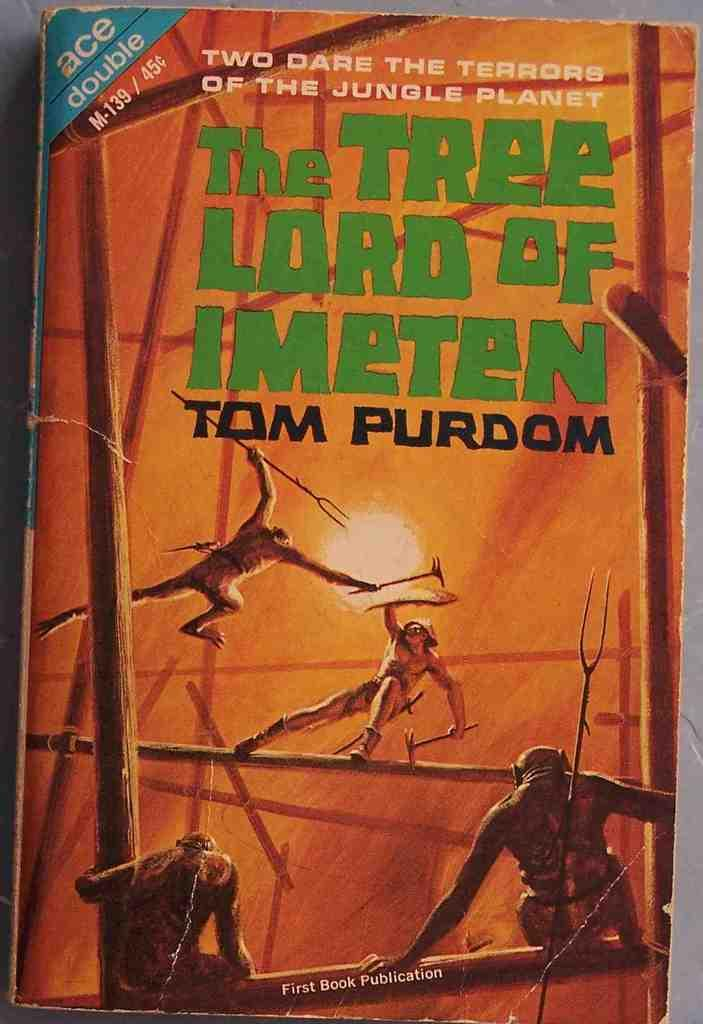<image>
Summarize the visual content of the image. An orange book cover titled The Tree Lord of Imeten. 